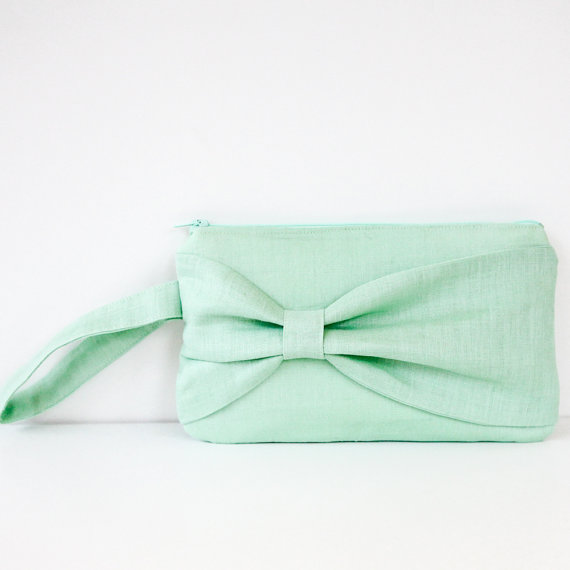If this purse were to be used in a movie, what kind of character would it belong to? In a movie, this clutch purse would likely belong to a character who exudes grace and timeless style, perhaps a young woman attending a high-society event or a sophisticated garden party. She is discerning in her fashion choices, opting for pieces that reflect her understated elegance and attention to detail. The mint green purse with its decorative bow speaks to her sense of poise and her knack for selecting accessories that perfectly complement her outfits. This character might be pivotal in the storyline, using her charm and sharp wit to navigate complex social situations and uncover hidden secrets. 